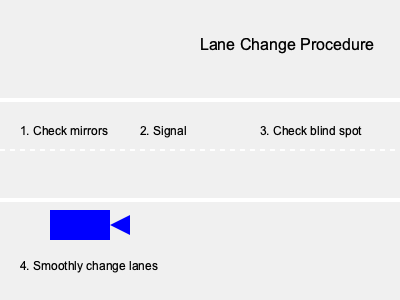As a driving examiner, which crucial step is missing from the lane change procedure shown in the diagram? The diagram illustrates a bird's-eye view of a proper lane changing procedure. Let's analyze the steps shown:

1. Check mirrors: This is correctly shown as the first step.
2. Signal: Indicating the intention to change lanes is the second step.
3. Check blind spot: This is crucial for safety and is shown as the third step.
4. Smoothly change lanes: The final action of moving into the new lane is depicted.

However, there is a critical step missing between checking the blind spot and actually changing lanes. This step is to assess if there is sufficient space in the target lane to safely complete the maneuver. 

As a driving examiner, it's important to emphasize that drivers should always ensure there is enough room in the adjacent lane before initiating the lane change. This assessment helps prevent cutting off other drivers or potentially causing accidents.

Therefore, the missing step in this procedure is to check for adequate space in the target lane.
Answer: Check for adequate space 